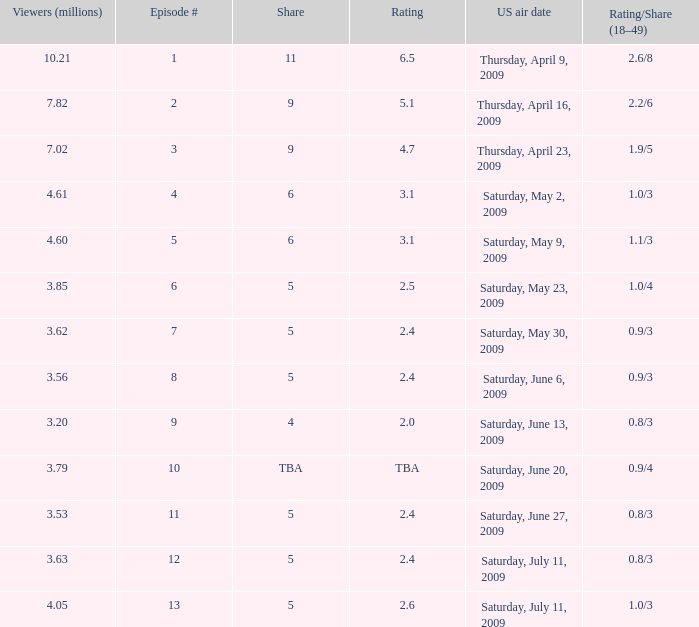What is the lowest number of million viewers for an episode before episode 5 with a rating/share of 1.1/3? None. 